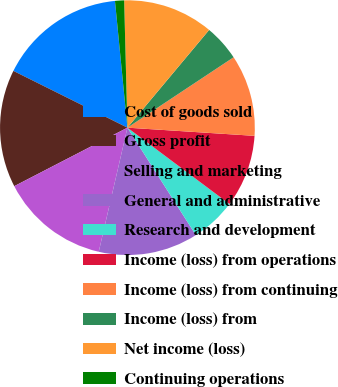<chart> <loc_0><loc_0><loc_500><loc_500><pie_chart><fcel>Cost of goods sold<fcel>Gross profit<fcel>Selling and marketing<fcel>General and administrative<fcel>Research and development<fcel>Income (loss) from operations<fcel>Income (loss) from continuing<fcel>Income (loss) from<fcel>Net income (loss)<fcel>Continuing operations<nl><fcel>16.09%<fcel>14.94%<fcel>13.79%<fcel>12.64%<fcel>5.75%<fcel>9.2%<fcel>10.34%<fcel>4.6%<fcel>11.49%<fcel>1.15%<nl></chart> 